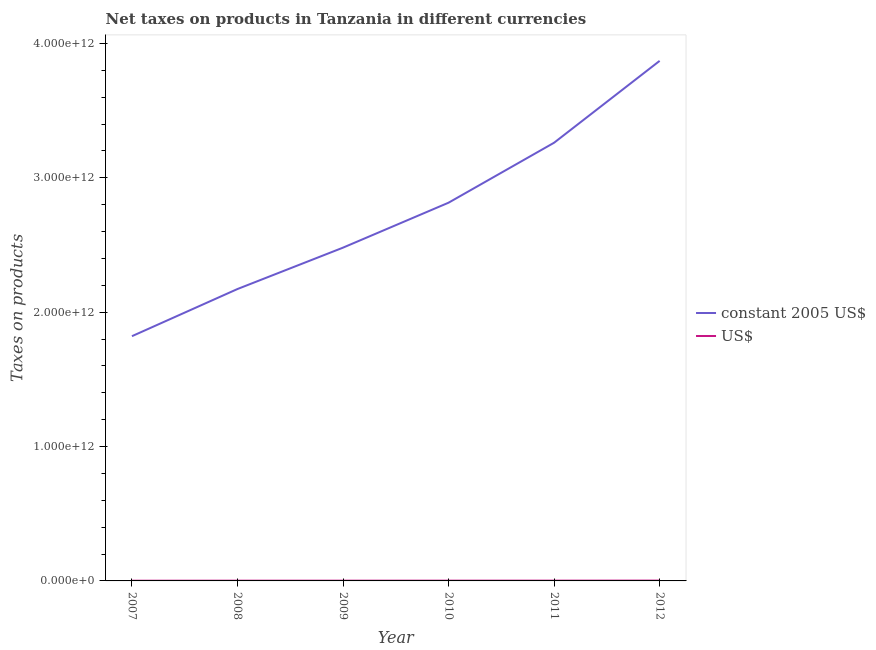Does the line corresponding to net taxes in us$ intersect with the line corresponding to net taxes in constant 2005 us$?
Ensure brevity in your answer.  No. Is the number of lines equal to the number of legend labels?
Keep it short and to the point. Yes. What is the net taxes in constant 2005 us$ in 2009?
Give a very brief answer. 2.48e+12. Across all years, what is the maximum net taxes in constant 2005 us$?
Your answer should be compact. 3.87e+12. Across all years, what is the minimum net taxes in us$?
Give a very brief answer. 1.46e+09. In which year was the net taxes in constant 2005 us$ minimum?
Provide a short and direct response. 2007. What is the total net taxes in us$ in the graph?
Keep it short and to the point. 1.17e+1. What is the difference between the net taxes in constant 2005 us$ in 2008 and that in 2012?
Provide a succinct answer. -1.70e+12. What is the difference between the net taxes in us$ in 2009 and the net taxes in constant 2005 us$ in 2010?
Your answer should be very brief. -2.81e+12. What is the average net taxes in us$ per year?
Offer a very short reply. 1.96e+09. In the year 2008, what is the difference between the net taxes in constant 2005 us$ and net taxes in us$?
Offer a very short reply. 2.17e+12. In how many years, is the net taxes in constant 2005 us$ greater than 200000000000 units?
Provide a succinct answer. 6. What is the ratio of the net taxes in constant 2005 us$ in 2008 to that in 2009?
Your answer should be compact. 0.88. What is the difference between the highest and the second highest net taxes in us$?
Your response must be concise. 3.69e+08. What is the difference between the highest and the lowest net taxes in constant 2005 us$?
Make the answer very short. 2.05e+12. In how many years, is the net taxes in constant 2005 us$ greater than the average net taxes in constant 2005 us$ taken over all years?
Make the answer very short. 3. Is the sum of the net taxes in constant 2005 us$ in 2008 and 2011 greater than the maximum net taxes in us$ across all years?
Make the answer very short. Yes. Is the net taxes in us$ strictly greater than the net taxes in constant 2005 us$ over the years?
Give a very brief answer. No. Is the net taxes in us$ strictly less than the net taxes in constant 2005 us$ over the years?
Your answer should be very brief. Yes. How many years are there in the graph?
Your answer should be very brief. 6. What is the difference between two consecutive major ticks on the Y-axis?
Offer a very short reply. 1.00e+12. Are the values on the major ticks of Y-axis written in scientific E-notation?
Offer a terse response. Yes. Does the graph contain any zero values?
Give a very brief answer. No. How are the legend labels stacked?
Provide a succinct answer. Vertical. What is the title of the graph?
Your answer should be compact. Net taxes on products in Tanzania in different currencies. Does "Old" appear as one of the legend labels in the graph?
Ensure brevity in your answer.  No. What is the label or title of the Y-axis?
Your response must be concise. Taxes on products. What is the Taxes on products in constant 2005 US$ in 2007?
Provide a short and direct response. 1.82e+12. What is the Taxes on products in US$ in 2007?
Your response must be concise. 1.46e+09. What is the Taxes on products of constant 2005 US$ in 2008?
Provide a short and direct response. 2.17e+12. What is the Taxes on products in US$ in 2008?
Your answer should be very brief. 1.81e+09. What is the Taxes on products in constant 2005 US$ in 2009?
Keep it short and to the point. 2.48e+12. What is the Taxes on products in US$ in 2009?
Offer a very short reply. 1.88e+09. What is the Taxes on products in constant 2005 US$ in 2010?
Provide a short and direct response. 2.82e+12. What is the Taxes on products in US$ in 2010?
Offer a terse response. 2.02e+09. What is the Taxes on products of constant 2005 US$ in 2011?
Offer a terse response. 3.26e+12. What is the Taxes on products of US$ in 2011?
Your response must be concise. 2.09e+09. What is the Taxes on products in constant 2005 US$ in 2012?
Your answer should be very brief. 3.87e+12. What is the Taxes on products in US$ in 2012?
Make the answer very short. 2.46e+09. Across all years, what is the maximum Taxes on products of constant 2005 US$?
Provide a succinct answer. 3.87e+12. Across all years, what is the maximum Taxes on products of US$?
Keep it short and to the point. 2.46e+09. Across all years, what is the minimum Taxes on products in constant 2005 US$?
Provide a succinct answer. 1.82e+12. Across all years, what is the minimum Taxes on products of US$?
Make the answer very short. 1.46e+09. What is the total Taxes on products in constant 2005 US$ in the graph?
Make the answer very short. 1.64e+13. What is the total Taxes on products of US$ in the graph?
Ensure brevity in your answer.  1.17e+1. What is the difference between the Taxes on products of constant 2005 US$ in 2007 and that in 2008?
Offer a terse response. -3.51e+11. What is the difference between the Taxes on products of US$ in 2007 and that in 2008?
Provide a short and direct response. -3.52e+08. What is the difference between the Taxes on products in constant 2005 US$ in 2007 and that in 2009?
Ensure brevity in your answer.  -6.59e+11. What is the difference between the Taxes on products of US$ in 2007 and that in 2009?
Provide a short and direct response. -4.16e+08. What is the difference between the Taxes on products in constant 2005 US$ in 2007 and that in 2010?
Make the answer very short. -9.94e+11. What is the difference between the Taxes on products in US$ in 2007 and that in 2010?
Make the answer very short. -5.54e+08. What is the difference between the Taxes on products in constant 2005 US$ in 2007 and that in 2011?
Your answer should be compact. -1.44e+12. What is the difference between the Taxes on products in US$ in 2007 and that in 2011?
Keep it short and to the point. -6.31e+08. What is the difference between the Taxes on products in constant 2005 US$ in 2007 and that in 2012?
Your response must be concise. -2.05e+12. What is the difference between the Taxes on products of US$ in 2007 and that in 2012?
Offer a terse response. -1.00e+09. What is the difference between the Taxes on products in constant 2005 US$ in 2008 and that in 2009?
Provide a succinct answer. -3.08e+11. What is the difference between the Taxes on products of US$ in 2008 and that in 2009?
Keep it short and to the point. -6.40e+07. What is the difference between the Taxes on products in constant 2005 US$ in 2008 and that in 2010?
Your answer should be compact. -6.43e+11. What is the difference between the Taxes on products of US$ in 2008 and that in 2010?
Offer a terse response. -2.02e+08. What is the difference between the Taxes on products in constant 2005 US$ in 2008 and that in 2011?
Your answer should be very brief. -1.09e+12. What is the difference between the Taxes on products in US$ in 2008 and that in 2011?
Offer a very short reply. -2.79e+08. What is the difference between the Taxes on products of constant 2005 US$ in 2008 and that in 2012?
Provide a short and direct response. -1.70e+12. What is the difference between the Taxes on products of US$ in 2008 and that in 2012?
Your answer should be very brief. -6.48e+08. What is the difference between the Taxes on products of constant 2005 US$ in 2009 and that in 2010?
Provide a succinct answer. -3.35e+11. What is the difference between the Taxes on products of US$ in 2009 and that in 2010?
Provide a short and direct response. -1.38e+08. What is the difference between the Taxes on products of constant 2005 US$ in 2009 and that in 2011?
Provide a succinct answer. -7.81e+11. What is the difference between the Taxes on products in US$ in 2009 and that in 2011?
Provide a succinct answer. -2.15e+08. What is the difference between the Taxes on products in constant 2005 US$ in 2009 and that in 2012?
Make the answer very short. -1.39e+12. What is the difference between the Taxes on products in US$ in 2009 and that in 2012?
Make the answer very short. -5.84e+08. What is the difference between the Taxes on products of constant 2005 US$ in 2010 and that in 2011?
Your answer should be very brief. -4.46e+11. What is the difference between the Taxes on products of US$ in 2010 and that in 2011?
Make the answer very short. -7.72e+07. What is the difference between the Taxes on products of constant 2005 US$ in 2010 and that in 2012?
Make the answer very short. -1.06e+12. What is the difference between the Taxes on products of US$ in 2010 and that in 2012?
Offer a terse response. -4.46e+08. What is the difference between the Taxes on products in constant 2005 US$ in 2011 and that in 2012?
Offer a very short reply. -6.09e+11. What is the difference between the Taxes on products of US$ in 2011 and that in 2012?
Offer a terse response. -3.69e+08. What is the difference between the Taxes on products in constant 2005 US$ in 2007 and the Taxes on products in US$ in 2008?
Make the answer very short. 1.82e+12. What is the difference between the Taxes on products of constant 2005 US$ in 2007 and the Taxes on products of US$ in 2009?
Ensure brevity in your answer.  1.82e+12. What is the difference between the Taxes on products in constant 2005 US$ in 2007 and the Taxes on products in US$ in 2010?
Keep it short and to the point. 1.82e+12. What is the difference between the Taxes on products in constant 2005 US$ in 2007 and the Taxes on products in US$ in 2011?
Give a very brief answer. 1.82e+12. What is the difference between the Taxes on products of constant 2005 US$ in 2007 and the Taxes on products of US$ in 2012?
Offer a very short reply. 1.82e+12. What is the difference between the Taxes on products in constant 2005 US$ in 2008 and the Taxes on products in US$ in 2009?
Provide a short and direct response. 2.17e+12. What is the difference between the Taxes on products in constant 2005 US$ in 2008 and the Taxes on products in US$ in 2010?
Offer a terse response. 2.17e+12. What is the difference between the Taxes on products of constant 2005 US$ in 2008 and the Taxes on products of US$ in 2011?
Your response must be concise. 2.17e+12. What is the difference between the Taxes on products of constant 2005 US$ in 2008 and the Taxes on products of US$ in 2012?
Keep it short and to the point. 2.17e+12. What is the difference between the Taxes on products of constant 2005 US$ in 2009 and the Taxes on products of US$ in 2010?
Offer a terse response. 2.48e+12. What is the difference between the Taxes on products in constant 2005 US$ in 2009 and the Taxes on products in US$ in 2011?
Ensure brevity in your answer.  2.48e+12. What is the difference between the Taxes on products in constant 2005 US$ in 2009 and the Taxes on products in US$ in 2012?
Offer a very short reply. 2.48e+12. What is the difference between the Taxes on products in constant 2005 US$ in 2010 and the Taxes on products in US$ in 2011?
Your answer should be compact. 2.81e+12. What is the difference between the Taxes on products in constant 2005 US$ in 2010 and the Taxes on products in US$ in 2012?
Provide a short and direct response. 2.81e+12. What is the difference between the Taxes on products in constant 2005 US$ in 2011 and the Taxes on products in US$ in 2012?
Your answer should be very brief. 3.26e+12. What is the average Taxes on products in constant 2005 US$ per year?
Your answer should be compact. 2.74e+12. What is the average Taxes on products of US$ per year?
Provide a succinct answer. 1.96e+09. In the year 2007, what is the difference between the Taxes on products of constant 2005 US$ and Taxes on products of US$?
Your response must be concise. 1.82e+12. In the year 2008, what is the difference between the Taxes on products in constant 2005 US$ and Taxes on products in US$?
Keep it short and to the point. 2.17e+12. In the year 2009, what is the difference between the Taxes on products of constant 2005 US$ and Taxes on products of US$?
Offer a very short reply. 2.48e+12. In the year 2010, what is the difference between the Taxes on products in constant 2005 US$ and Taxes on products in US$?
Offer a very short reply. 2.81e+12. In the year 2011, what is the difference between the Taxes on products of constant 2005 US$ and Taxes on products of US$?
Keep it short and to the point. 3.26e+12. In the year 2012, what is the difference between the Taxes on products of constant 2005 US$ and Taxes on products of US$?
Provide a short and direct response. 3.87e+12. What is the ratio of the Taxes on products in constant 2005 US$ in 2007 to that in 2008?
Give a very brief answer. 0.84. What is the ratio of the Taxes on products in US$ in 2007 to that in 2008?
Your answer should be very brief. 0.81. What is the ratio of the Taxes on products of constant 2005 US$ in 2007 to that in 2009?
Offer a terse response. 0.73. What is the ratio of the Taxes on products of US$ in 2007 to that in 2009?
Keep it short and to the point. 0.78. What is the ratio of the Taxes on products in constant 2005 US$ in 2007 to that in 2010?
Offer a terse response. 0.65. What is the ratio of the Taxes on products of US$ in 2007 to that in 2010?
Offer a terse response. 0.73. What is the ratio of the Taxes on products of constant 2005 US$ in 2007 to that in 2011?
Offer a very short reply. 0.56. What is the ratio of the Taxes on products of US$ in 2007 to that in 2011?
Your answer should be very brief. 0.7. What is the ratio of the Taxes on products in constant 2005 US$ in 2007 to that in 2012?
Keep it short and to the point. 0.47. What is the ratio of the Taxes on products of US$ in 2007 to that in 2012?
Your answer should be compact. 0.59. What is the ratio of the Taxes on products of constant 2005 US$ in 2008 to that in 2009?
Your answer should be very brief. 0.88. What is the ratio of the Taxes on products of US$ in 2008 to that in 2009?
Make the answer very short. 0.97. What is the ratio of the Taxes on products in constant 2005 US$ in 2008 to that in 2010?
Ensure brevity in your answer.  0.77. What is the ratio of the Taxes on products of US$ in 2008 to that in 2010?
Provide a succinct answer. 0.9. What is the ratio of the Taxes on products in constant 2005 US$ in 2008 to that in 2011?
Offer a very short reply. 0.67. What is the ratio of the Taxes on products in US$ in 2008 to that in 2011?
Your answer should be very brief. 0.87. What is the ratio of the Taxes on products in constant 2005 US$ in 2008 to that in 2012?
Offer a terse response. 0.56. What is the ratio of the Taxes on products in US$ in 2008 to that in 2012?
Ensure brevity in your answer.  0.74. What is the ratio of the Taxes on products of constant 2005 US$ in 2009 to that in 2010?
Provide a short and direct response. 0.88. What is the ratio of the Taxes on products in US$ in 2009 to that in 2010?
Provide a short and direct response. 0.93. What is the ratio of the Taxes on products of constant 2005 US$ in 2009 to that in 2011?
Your response must be concise. 0.76. What is the ratio of the Taxes on products of US$ in 2009 to that in 2011?
Give a very brief answer. 0.9. What is the ratio of the Taxes on products of constant 2005 US$ in 2009 to that in 2012?
Ensure brevity in your answer.  0.64. What is the ratio of the Taxes on products in US$ in 2009 to that in 2012?
Offer a terse response. 0.76. What is the ratio of the Taxes on products of constant 2005 US$ in 2010 to that in 2011?
Your answer should be very brief. 0.86. What is the ratio of the Taxes on products in US$ in 2010 to that in 2011?
Give a very brief answer. 0.96. What is the ratio of the Taxes on products in constant 2005 US$ in 2010 to that in 2012?
Your response must be concise. 0.73. What is the ratio of the Taxes on products in US$ in 2010 to that in 2012?
Provide a succinct answer. 0.82. What is the ratio of the Taxes on products of constant 2005 US$ in 2011 to that in 2012?
Offer a very short reply. 0.84. What is the ratio of the Taxes on products in US$ in 2011 to that in 2012?
Keep it short and to the point. 0.85. What is the difference between the highest and the second highest Taxes on products of constant 2005 US$?
Offer a very short reply. 6.09e+11. What is the difference between the highest and the second highest Taxes on products in US$?
Ensure brevity in your answer.  3.69e+08. What is the difference between the highest and the lowest Taxes on products of constant 2005 US$?
Make the answer very short. 2.05e+12. What is the difference between the highest and the lowest Taxes on products in US$?
Your response must be concise. 1.00e+09. 